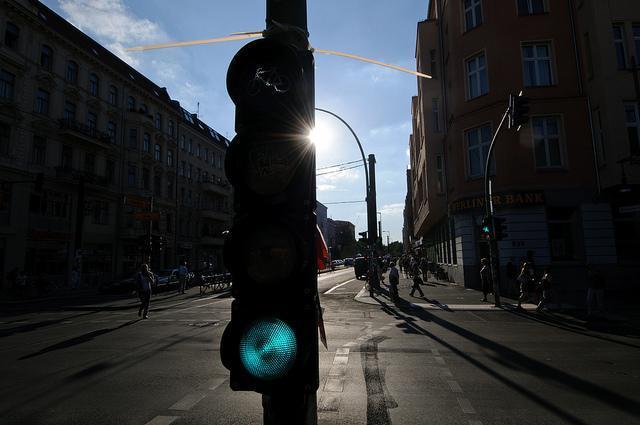How many traffic lights are there?
Give a very brief answer. 2. 